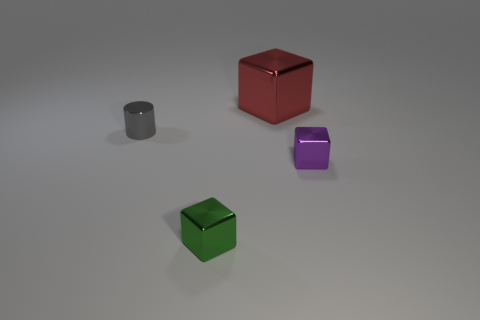Add 2 green metallic things. How many objects exist? 6 Subtract all cylinders. How many objects are left? 3 Subtract all green shiny blocks. How many blocks are left? 2 Subtract all big red metal cubes. Subtract all tiny shiny things. How many objects are left? 0 Add 4 large red shiny objects. How many large red shiny objects are left? 5 Add 2 large gray metallic objects. How many large gray metallic objects exist? 2 Subtract 0 green balls. How many objects are left? 4 Subtract 1 cylinders. How many cylinders are left? 0 Subtract all brown cylinders. Subtract all blue cubes. How many cylinders are left? 1 Subtract all gray spheres. How many purple cubes are left? 1 